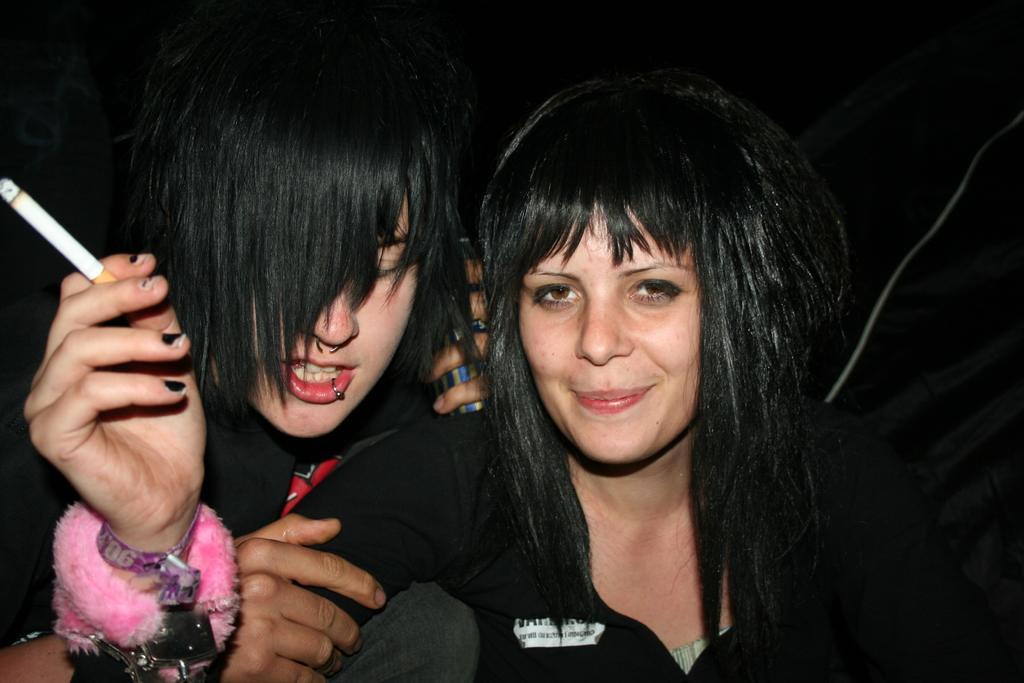Please provide a concise description of this image. There are two ladies. Lady on the right is wearing wrist bands and holding a cigarette. Other lady is holding something in the back. In the background it is dark. 